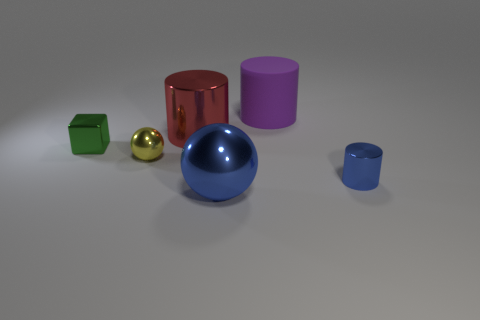What number of objects have the same color as the small cylinder?
Ensure brevity in your answer.  1. Does the red cylinder have the same material as the blue cylinder?
Ensure brevity in your answer.  Yes. What number of things are tiny red matte spheres or purple cylinders?
Your answer should be compact. 1. What shape is the blue object that is to the left of the purple rubber object?
Provide a short and direct response. Sphere. What color is the large cylinder that is made of the same material as the block?
Make the answer very short. Red. There is a blue thing that is the same shape as the yellow shiny thing; what material is it?
Give a very brief answer. Metal. What is the shape of the big red object?
Your answer should be very brief. Cylinder. The cylinder that is both on the right side of the large blue metal object and behind the small cylinder is made of what material?
Your response must be concise. Rubber. What is the shape of the small blue object that is the same material as the green block?
Your answer should be very brief. Cylinder. There is a blue ball that is the same material as the small green cube; what is its size?
Provide a succinct answer. Large. 